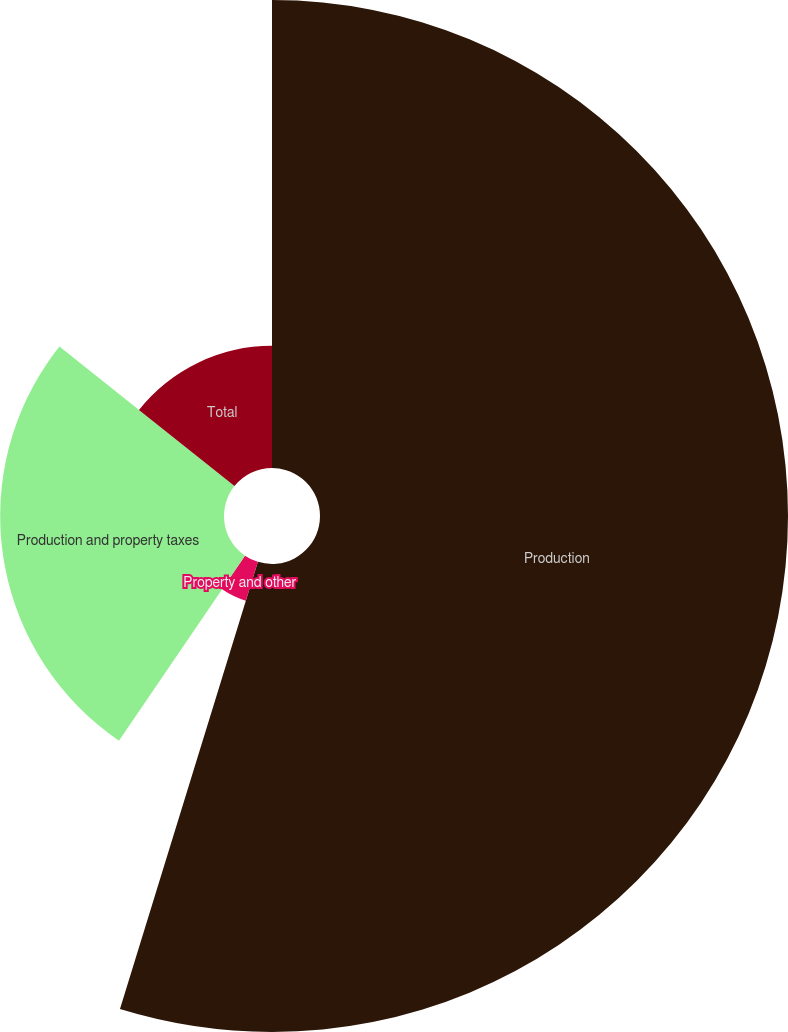Convert chart. <chart><loc_0><loc_0><loc_500><loc_500><pie_chart><fcel>Production<fcel>Property and other<fcel>Production and property taxes<fcel>Total<nl><fcel>54.76%<fcel>4.76%<fcel>26.19%<fcel>14.29%<nl></chart> 